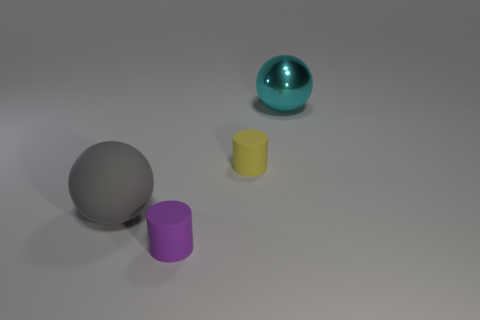Does the yellow thing have the same shape as the purple matte thing?
Ensure brevity in your answer.  Yes. How many things are either things left of the tiny yellow object or cyan metallic balls?
Provide a short and direct response. 3. What is the shape of the large thing on the left side of the big ball that is behind the big object that is in front of the big cyan shiny ball?
Make the answer very short. Sphere. What shape is the small yellow thing that is the same material as the tiny purple object?
Your response must be concise. Cylinder. What size is the gray ball?
Offer a very short reply. Large. Does the purple matte cylinder have the same size as the gray rubber ball?
Give a very brief answer. No. What number of objects are either things that are on the left side of the large cyan ball or big balls behind the yellow cylinder?
Give a very brief answer. 4. How many large gray rubber spheres are in front of the matte cylinder that is in front of the tiny cylinder behind the large matte object?
Provide a succinct answer. 0. There is a rubber ball that is on the left side of the tiny purple object; what size is it?
Give a very brief answer. Large. How many gray balls have the same size as the cyan metallic thing?
Give a very brief answer. 1. 